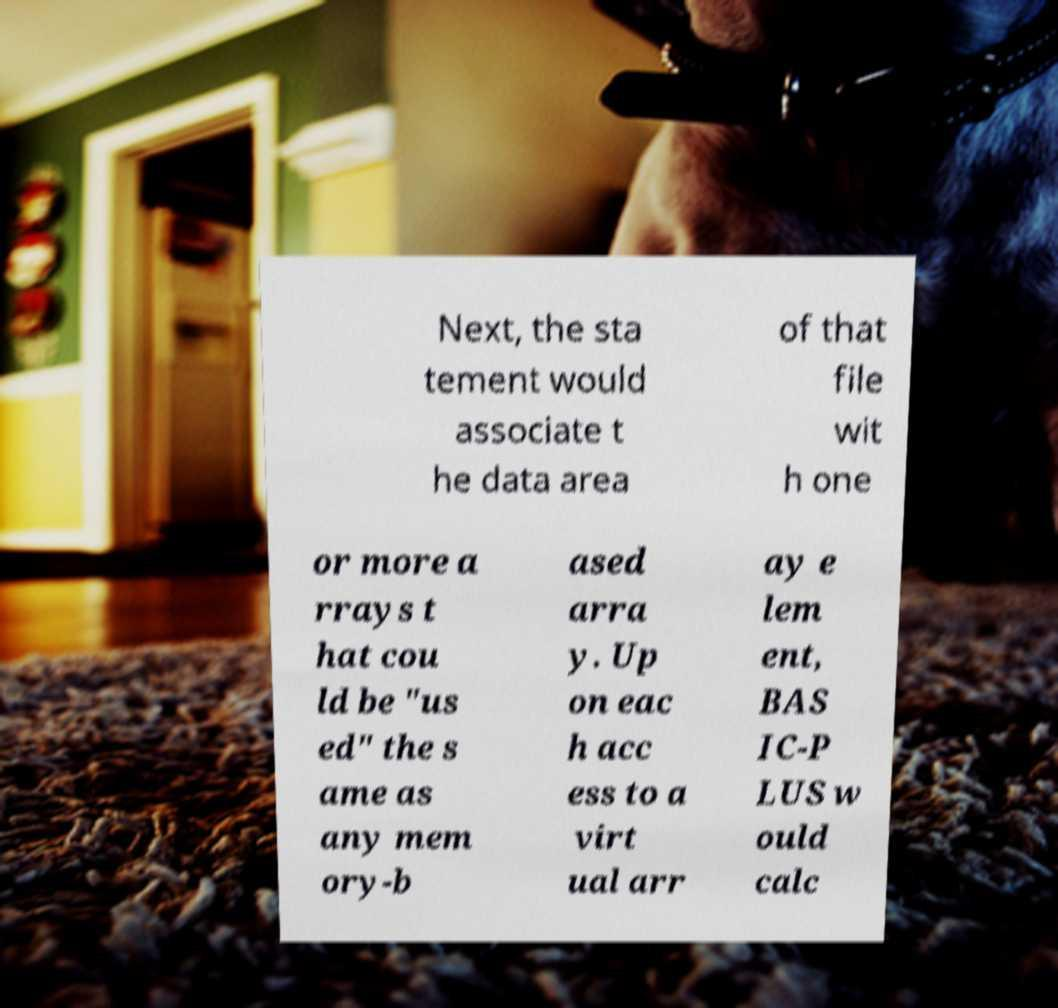Please read and relay the text visible in this image. What does it say? Next, the sta tement would associate t he data area of that file wit h one or more a rrays t hat cou ld be "us ed" the s ame as any mem ory-b ased arra y. Up on eac h acc ess to a virt ual arr ay e lem ent, BAS IC-P LUS w ould calc 